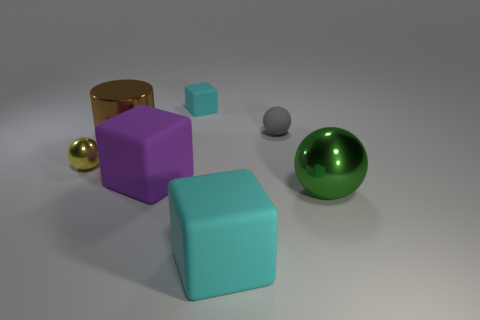Are there an equal number of tiny yellow things in front of the tiny yellow ball and metal spheres?
Your response must be concise. No. Is the small shiny sphere the same color as the large shiny cylinder?
Your answer should be very brief. No. There is a large shiny object in front of the brown metallic thing; does it have the same shape as the big metallic object left of the small block?
Offer a terse response. No. There is another cyan thing that is the same shape as the small cyan matte object; what is it made of?
Offer a terse response. Rubber. The tiny object that is both right of the brown cylinder and in front of the tiny cube is what color?
Your response must be concise. Gray. There is a cyan block that is behind the cyan matte thing that is in front of the yellow thing; is there a cylinder that is on the right side of it?
Provide a short and direct response. No. How many objects are large brown cubes or cubes?
Keep it short and to the point. 3. Is the material of the tiny yellow sphere the same as the cyan cube that is behind the big purple rubber block?
Give a very brief answer. No. Is there anything else that is the same color as the cylinder?
Provide a succinct answer. No. How many things are small gray balls that are in front of the small cyan block or rubber cubes behind the green metallic thing?
Offer a terse response. 3. 